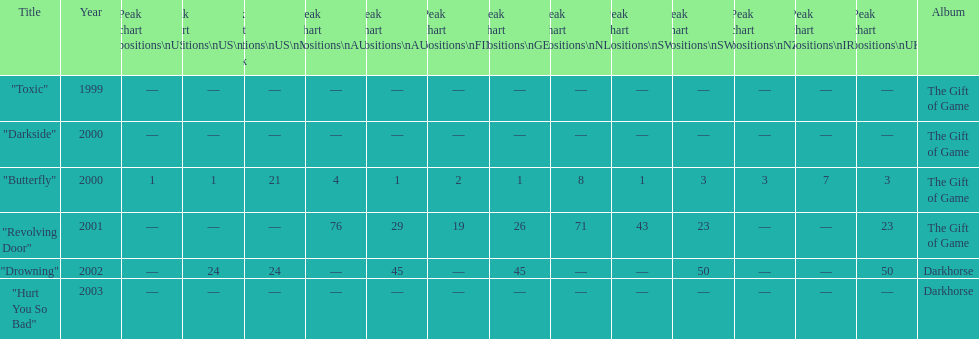By how many chart positions higher did "revolving door" peak in the uk compared to the peak position of "drowning" in the uk? 27. 